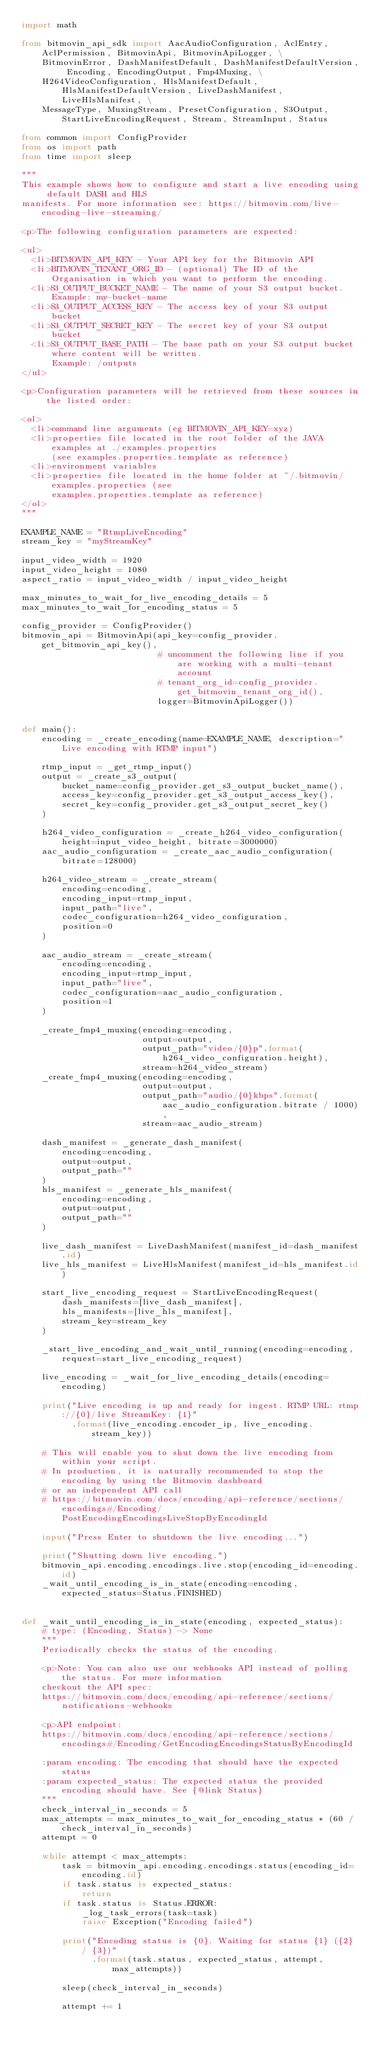Convert code to text. <code><loc_0><loc_0><loc_500><loc_500><_Python_>import math

from bitmovin_api_sdk import AacAudioConfiguration, AclEntry, AclPermission, BitmovinApi, BitmovinApiLogger, \
    BitmovinError, DashManifestDefault, DashManifestDefaultVersion, Encoding, EncodingOutput, Fmp4Muxing, \
    H264VideoConfiguration, HlsManifestDefault, HlsManifestDefaultVersion, LiveDashManifest, LiveHlsManifest, \
    MessageType, MuxingStream, PresetConfiguration, S3Output, StartLiveEncodingRequest, Stream, StreamInput, Status

from common import ConfigProvider
from os import path
from time import sleep

"""
This example shows how to configure and start a live encoding using default DASH and HLS
manifests. For more information see: https://bitmovin.com/live-encoding-live-streaming/

<p>The following configuration parameters are expected:

<ul>
  <li>BITMOVIN_API_KEY - Your API key for the Bitmovin API
  <li>BITMOVIN_TENANT_ORG_ID - (optional) The ID of the Organisation in which you want to perform the encoding.
  <li>S3_OUTPUT_BUCKET_NAME - The name of your S3 output bucket. Example: my-bucket-name
  <li>S3_OUTPUT_ACCESS_KEY - The access key of your S3 output bucket
  <li>S3_OUTPUT_SECRET_KEY - The secret key of your S3 output bucket
  <li>S3_OUTPUT_BASE_PATH - The base path on your S3 output bucket where content will be written.
      Example: /outputs
</ul>

<p>Configuration parameters will be retrieved from these sources in the listed order:

<ol>
  <li>command line arguments (eg BITMOVIN_API_KEY=xyz)
  <li>properties file located in the root folder of the JAVA examples at ./examples.properties
      (see examples.properties.template as reference)
  <li>environment variables
  <li>properties file located in the home folder at ~/.bitmovin/examples.properties (see
      examples.properties.template as reference)
</ol>
"""

EXAMPLE_NAME = "RtmpLiveEncoding"
stream_key = "myStreamKey"

input_video_width = 1920
input_video_height = 1080
aspect_ratio = input_video_width / input_video_height

max_minutes_to_wait_for_live_encoding_details = 5
max_minutes_to_wait_for_encoding_status = 5

config_provider = ConfigProvider()
bitmovin_api = BitmovinApi(api_key=config_provider.get_bitmovin_api_key(),
                           # uncomment the following line if you are working with a multi-tenant account
                           # tenant_org_id=config_provider.get_bitmovin_tenant_org_id(),
                           logger=BitmovinApiLogger())


def main():
    encoding = _create_encoding(name=EXAMPLE_NAME, description="Live encoding with RTMP input")

    rtmp_input = _get_rtmp_input()
    output = _create_s3_output(
        bucket_name=config_provider.get_s3_output_bucket_name(),
        access_key=config_provider.get_s3_output_access_key(),
        secret_key=config_provider.get_s3_output_secret_key()
    )

    h264_video_configuration = _create_h264_video_configuration(height=input_video_height, bitrate=3000000)
    aac_audio_configuration = _create_aac_audio_configuration(bitrate=128000)

    h264_video_stream = _create_stream(
        encoding=encoding,
        encoding_input=rtmp_input,
        input_path="live",
        codec_configuration=h264_video_configuration,
        position=0
    )

    aac_audio_stream = _create_stream(
        encoding=encoding,
        encoding_input=rtmp_input,
        input_path="live",
        codec_configuration=aac_audio_configuration,
        position=1
    )

    _create_fmp4_muxing(encoding=encoding,
                        output=output,
                        output_path="video/{0}p".format(h264_video_configuration.height),
                        stream=h264_video_stream)
    _create_fmp4_muxing(encoding=encoding,
                        output=output,
                        output_path="audio/{0}kbps".format(aac_audio_configuration.bitrate / 1000),
                        stream=aac_audio_stream)

    dash_manifest = _generate_dash_manifest(
        encoding=encoding,
        output=output,
        output_path=""
    )
    hls_manifest = _generate_hls_manifest(
        encoding=encoding,
        output=output,
        output_path=""
    )

    live_dash_manifest = LiveDashManifest(manifest_id=dash_manifest.id)
    live_hls_manifest = LiveHlsManifest(manifest_id=hls_manifest.id)

    start_live_encoding_request = StartLiveEncodingRequest(
        dash_manifests=[live_dash_manifest],
        hls_manifests=[live_hls_manifest],
        stream_key=stream_key
    )

    _start_live_encoding_and_wait_until_running(encoding=encoding, request=start_live_encoding_request)

    live_encoding = _wait_for_live_encoding_details(encoding=encoding)

    print("Live encoding is up and ready for ingest. RTMP URL: rtmp://{0}/live StreamKey: {1}"
          .format(live_encoding.encoder_ip, live_encoding.stream_key))

    # This will enable you to shut down the live encoding from within your script.
    # In production, it is naturally recommended to stop the encoding by using the Bitmovin dashboard
    # or an independent API call
    # https://bitmovin.com/docs/encoding/api-reference/sections/encodings#/Encoding/PostEncodingEncodingsLiveStopByEncodingId

    input("Press Enter to shutdown the live encoding...")

    print("Shutting down live encoding.")
    bitmovin_api.encoding.encodings.live.stop(encoding_id=encoding.id)
    _wait_until_encoding_is_in_state(encoding=encoding, expected_status=Status.FINISHED)


def _wait_until_encoding_is_in_state(encoding, expected_status):
    # type: (Encoding, Status) -> None
    """
    Periodically checks the status of the encoding.

    <p>Note: You can also use our webhooks API instead of polling the status. For more information
    checkout the API spec:
    https://bitmovin.com/docs/encoding/api-reference/sections/notifications-webhooks

    <p>API endpoint:
    https://bitmovin.com/docs/encoding/api-reference/sections/encodings#/Encoding/GetEncodingEncodingsStatusByEncodingId

    :param encoding: The encoding that should have the expected status
    :param expected_status: The expected status the provided encoding should have. See {@link Status}
    """
    check_interval_in_seconds = 5
    max_attempts = max_minutes_to_wait_for_encoding_status * (60 / check_interval_in_seconds)
    attempt = 0

    while attempt < max_attempts:
        task = bitmovin_api.encoding.encodings.status(encoding_id=encoding.id)
        if task.status is expected_status:
            return
        if task.status is Status.ERROR:
            _log_task_errors(task=task)
            raise Exception("Encoding failed")

        print("Encoding status is {0}. Waiting for status {1} ({2} / {3})"
              .format(task.status, expected_status, attempt, max_attempts))

        sleep(check_interval_in_seconds)

        attempt += 1
</code> 